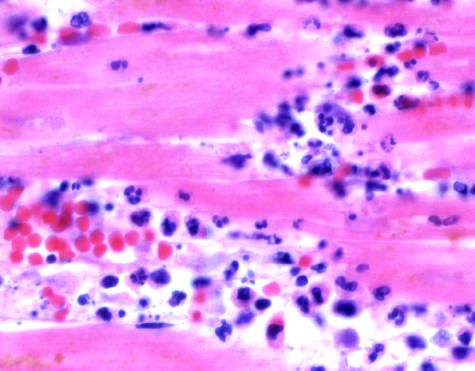when do the photomicrographs show an inflammatory reaction in the myocardium?
Answer the question using a single word or phrase. After ischemic necrosis infarction 